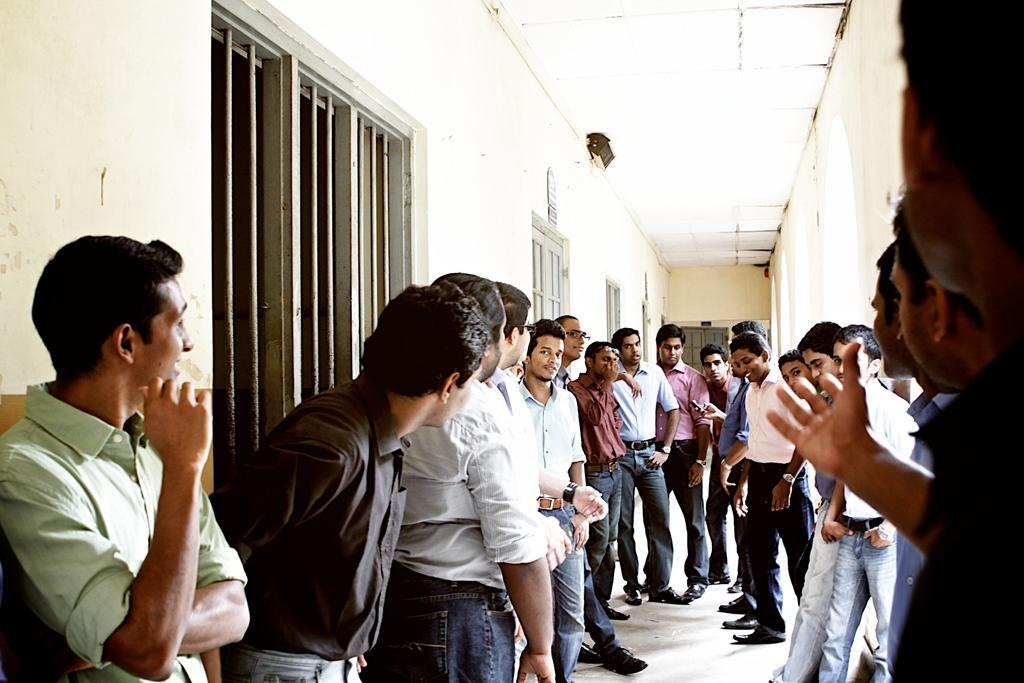What can be seen in the image? There are people standing in the image. Where are the people standing? The people are standing on the floor. What is visible on the left side of the image? There are windows on the left side of the image. What is visible on the right side of the image? There is a wall on the right side of the image. What is attached to the ceiling in the image? There is a light attached to the ceiling in the image. What type of thrill can be seen on the faces of the people in the image? There is no indication of any specific emotion or thrill on the faces of the people in the image. 